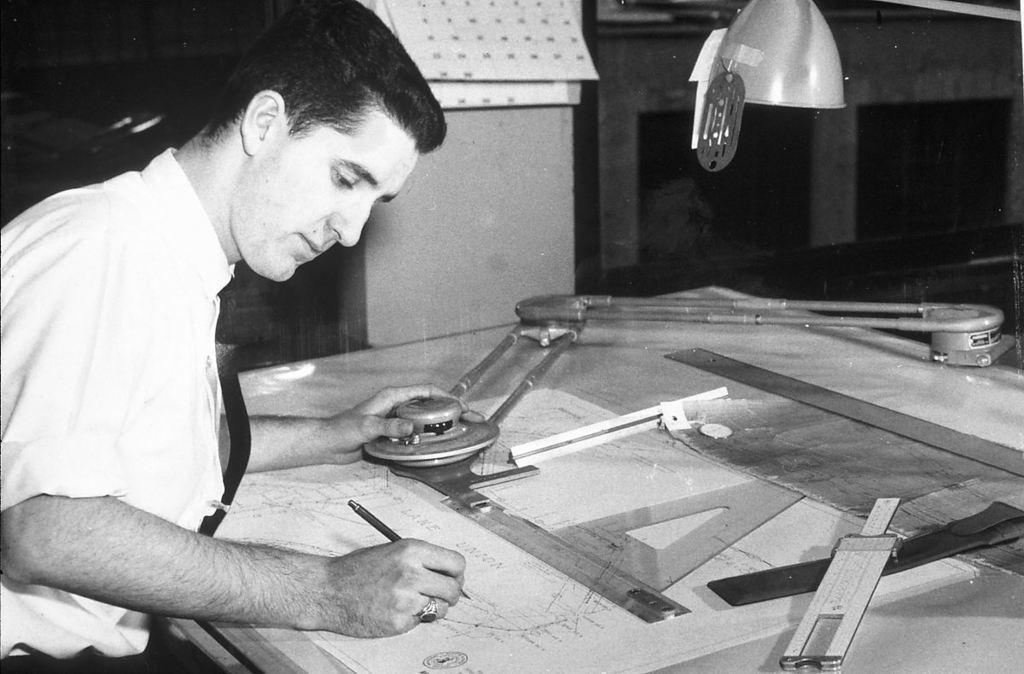Who is present in the image? There is a man in the picture. What is in front of the man? There is a table in front of the man. What items can be seen on the table? There are papers and scales on the table. What type of flower is on the table in the image? There is no flower present on the table in the image. Can you explain the reason behind the man's presence in the image? The image does not provide any information about the man's purpose or reason for being in the image. 